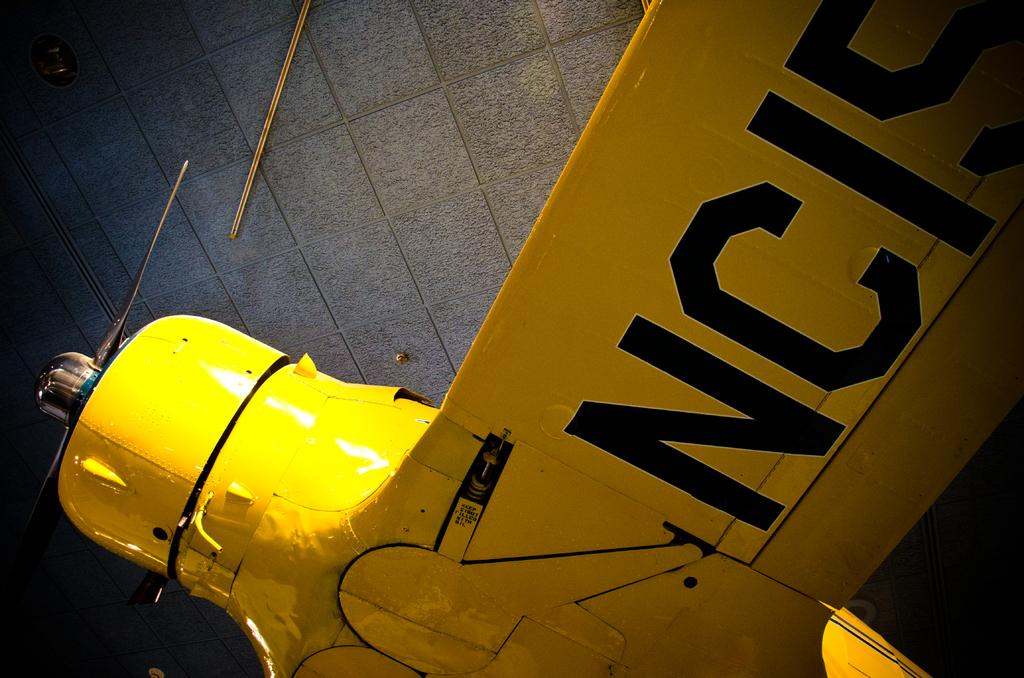<image>
Give a short and clear explanation of the subsequent image. A yellow hydrant next to an NCIS sign. 